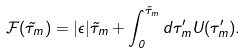<formula> <loc_0><loc_0><loc_500><loc_500>\mathcal { F } ( \tilde { \tau } _ { m } ) = | \epsilon | \tilde { \tau } _ { m } + \int _ { 0 } ^ { \tilde { \tau } _ { m } } d \tau _ { m } ^ { \prime } U ( \tau _ { m } ^ { \prime } ) .</formula> 